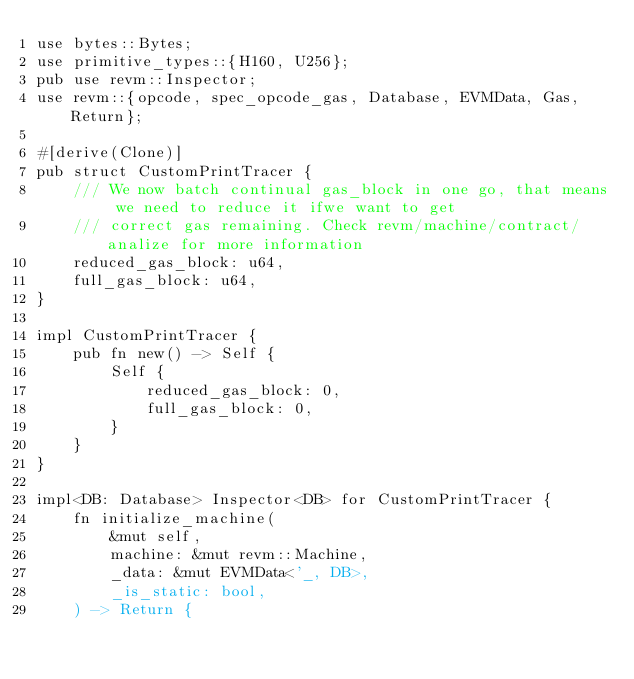Convert code to text. <code><loc_0><loc_0><loc_500><loc_500><_Rust_>use bytes::Bytes;
use primitive_types::{H160, U256};
pub use revm::Inspector;
use revm::{opcode, spec_opcode_gas, Database, EVMData, Gas, Return};

#[derive(Clone)]
pub struct CustomPrintTracer {
    /// We now batch continual gas_block in one go, that means we need to reduce it ifwe want to get
    /// correct gas remaining. Check revm/machine/contract/analize for more information
    reduced_gas_block: u64,
    full_gas_block: u64,
}

impl CustomPrintTracer {
    pub fn new() -> Self {
        Self {
            reduced_gas_block: 0,
            full_gas_block: 0,
        }
    }
}

impl<DB: Database> Inspector<DB> for CustomPrintTracer {
    fn initialize_machine(
        &mut self,
        machine: &mut revm::Machine,
        _data: &mut EVMData<'_, DB>,
        _is_static: bool,
    ) -> Return {</code> 